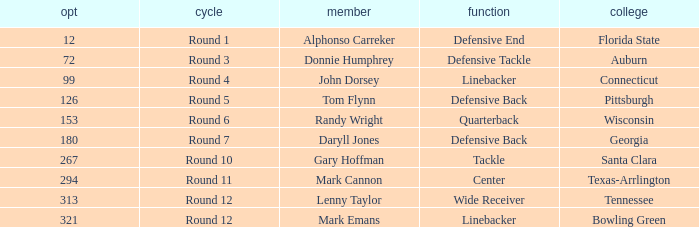In what Round was a player from College of Connecticut drafted? Round 4. 